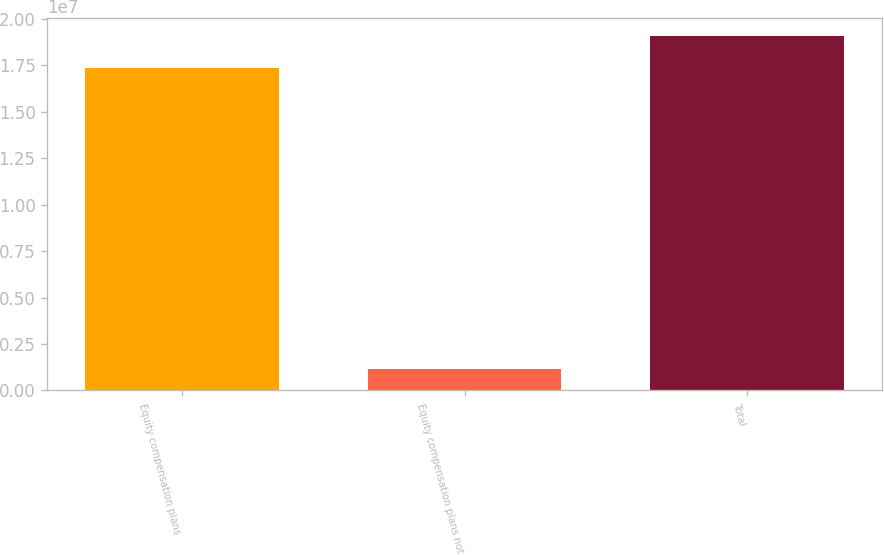Convert chart to OTSL. <chart><loc_0><loc_0><loc_500><loc_500><bar_chart><fcel>Equity compensation plans<fcel>Equity compensation plans not<fcel>Total<nl><fcel>1.73495e+07<fcel>1.14768e+06<fcel>1.90845e+07<nl></chart> 